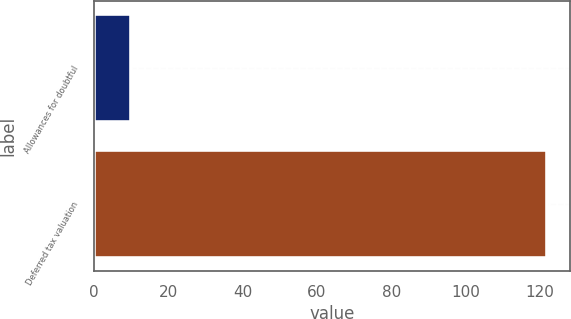Convert chart to OTSL. <chart><loc_0><loc_0><loc_500><loc_500><bar_chart><fcel>Allowances for doubtful<fcel>Deferred tax valuation<nl><fcel>10<fcel>122<nl></chart> 